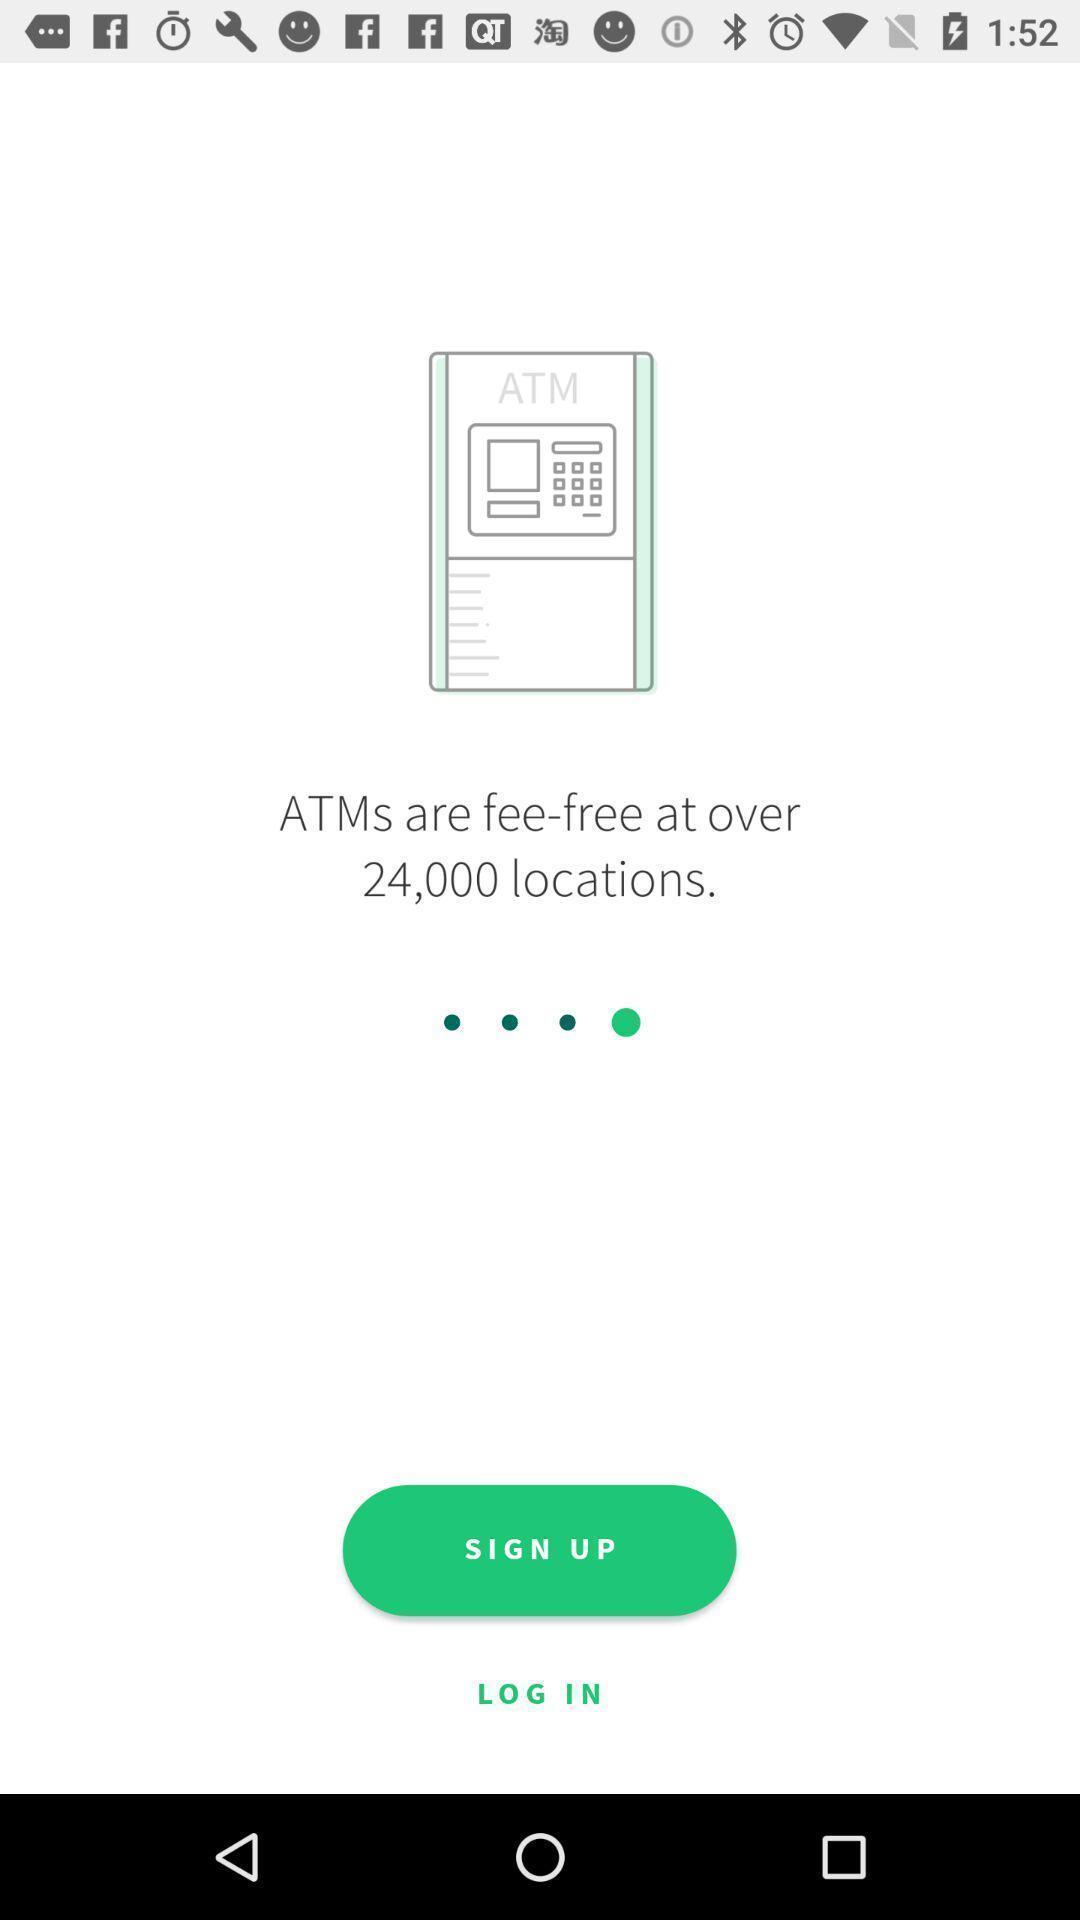Tell me about the visual elements in this screen capture. Welcome page for an atm locator app. 